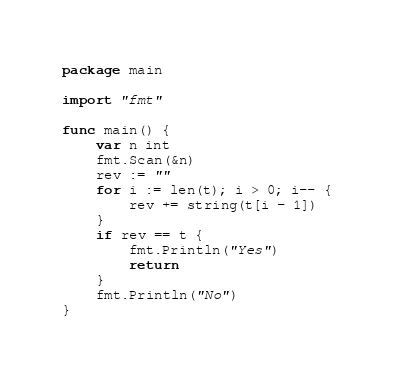<code> <loc_0><loc_0><loc_500><loc_500><_Go_>package main

import "fmt"

func main() {
	var n int
	fmt.Scan(&n)
	rev := ""
	for i := len(t); i > 0; i-- {
		rev += string(t[i - 1])
	}
	if rev == t {
		fmt.Println("Yes")
		return
	}
	fmt.Println("No")
}
</code> 